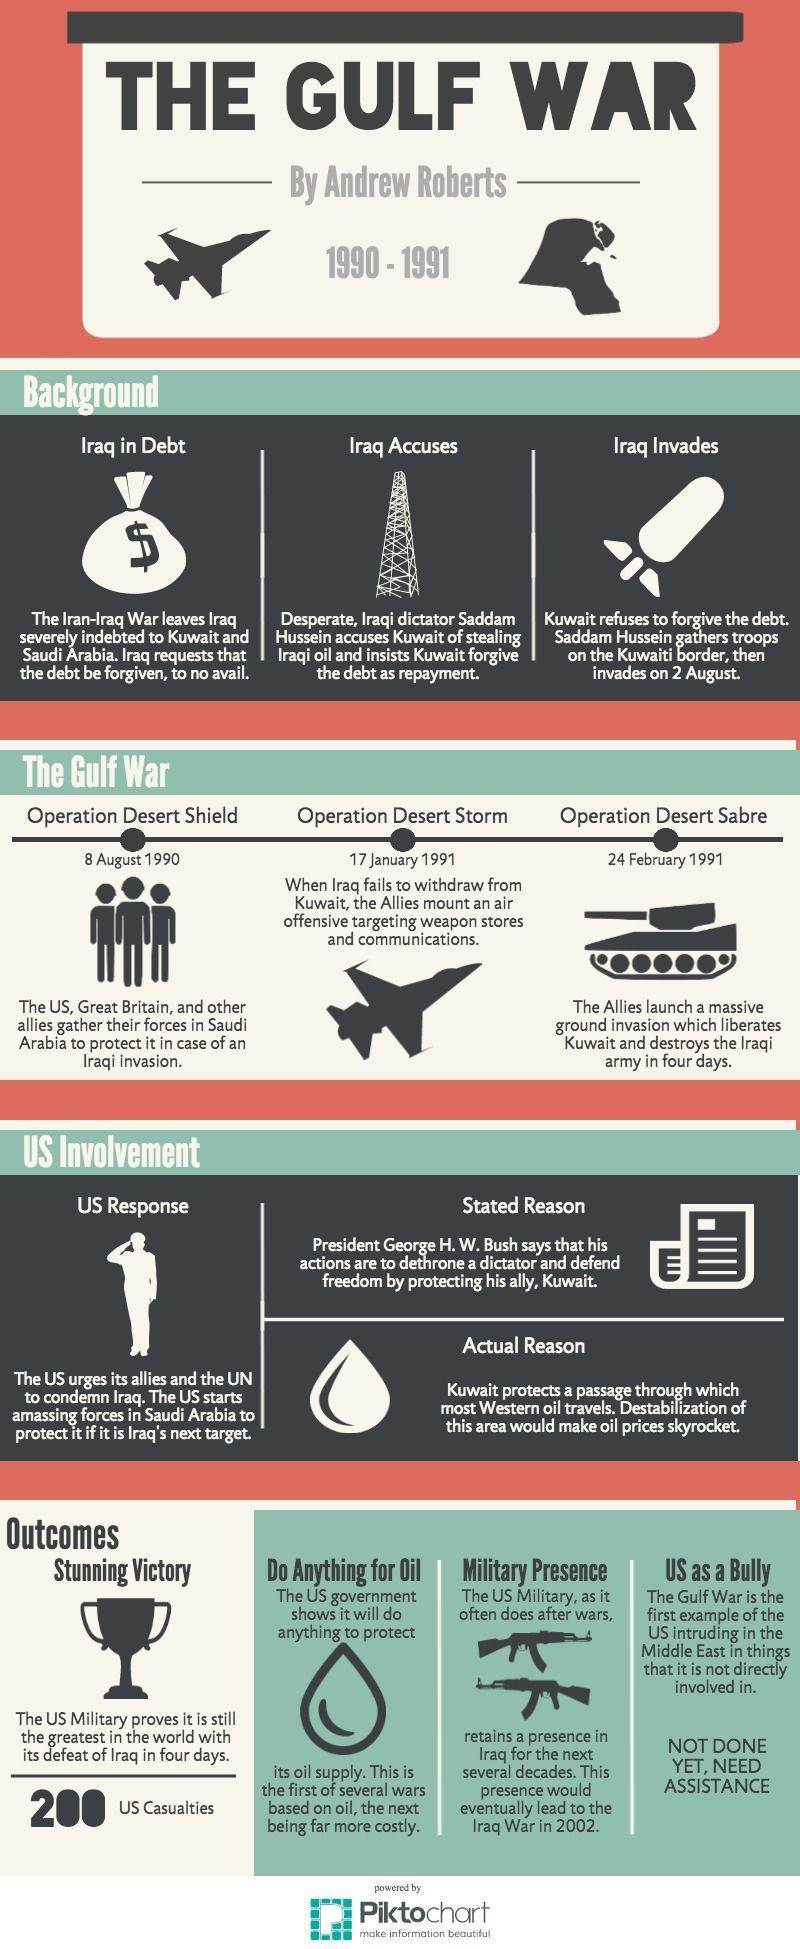When did the Allies launch ground invasion against Iraq?
Answer the question with a short phrase. 24 February 1991 How long did it take for the US to defeat Iraq? 4 days Which operation was aimed to protect Saudi Arabia from an invasion? Operation desert shield Under whose leadership did Iraq invade Kuwait? Saddam Hussein Which of the three operations took place second? Operation desert storm Under whose leadership did the US take part in the gulf war? President George H.W. Bush What were the three operations waged against Iraq? Operation desert shield, operation desert storm, operation desert Sabre When did the Allies launch an air invasion against Iraq's weapon stores and communications? 17 January 1991 When was operation desert Sabre launched? 24 February 1991 When was operation desert storm launched? 17 January 1991 When was operation desert shield launched? 8 August 1990 To which two countries was Iraq indebted after the Iran-Iraq war? Kuwait and Saudi Arabia On what date did Iraq invade Kuwait in 1990? 2 August What was the actual reason for the US involvement in the Gulf war, to protect Kuwait or to stop the oil prices from shooting up? To stop the oil prices from shooting up 